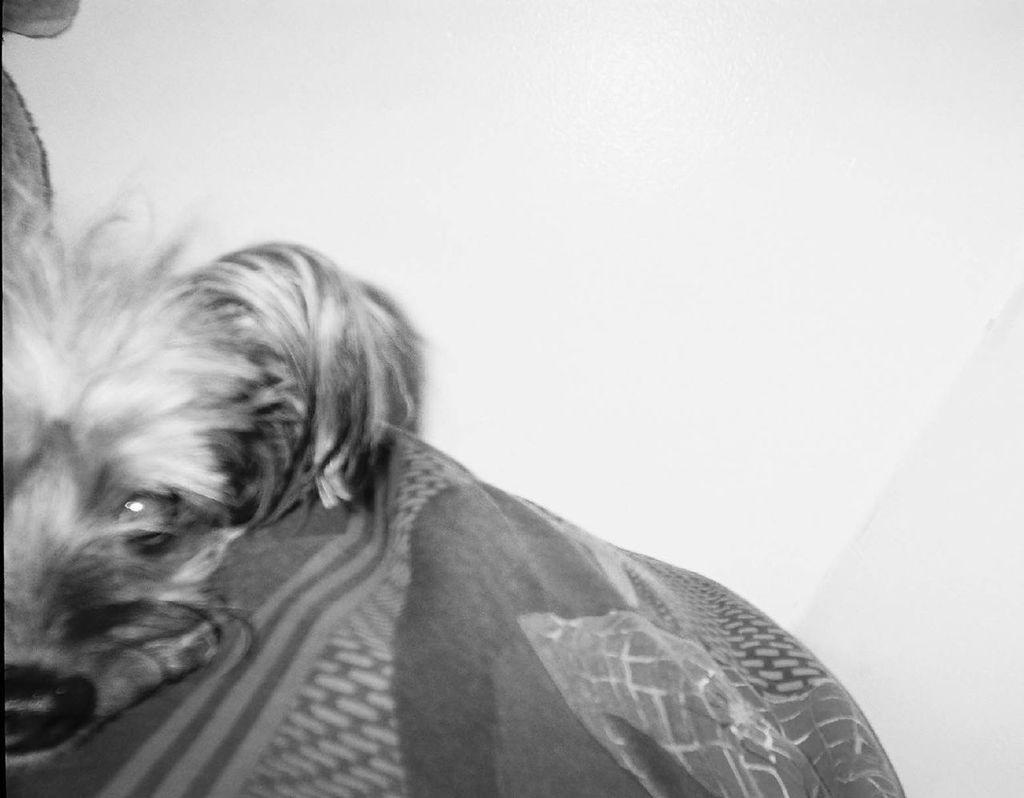Describe this image in one or two sentences. In this picture we can see a dog wrapped in a cloth. Background is white in color. 